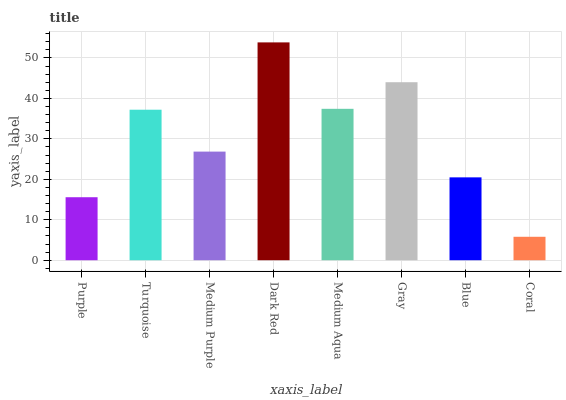Is Turquoise the minimum?
Answer yes or no. No. Is Turquoise the maximum?
Answer yes or no. No. Is Turquoise greater than Purple?
Answer yes or no. Yes. Is Purple less than Turquoise?
Answer yes or no. Yes. Is Purple greater than Turquoise?
Answer yes or no. No. Is Turquoise less than Purple?
Answer yes or no. No. Is Turquoise the high median?
Answer yes or no. Yes. Is Medium Purple the low median?
Answer yes or no. Yes. Is Blue the high median?
Answer yes or no. No. Is Gray the low median?
Answer yes or no. No. 